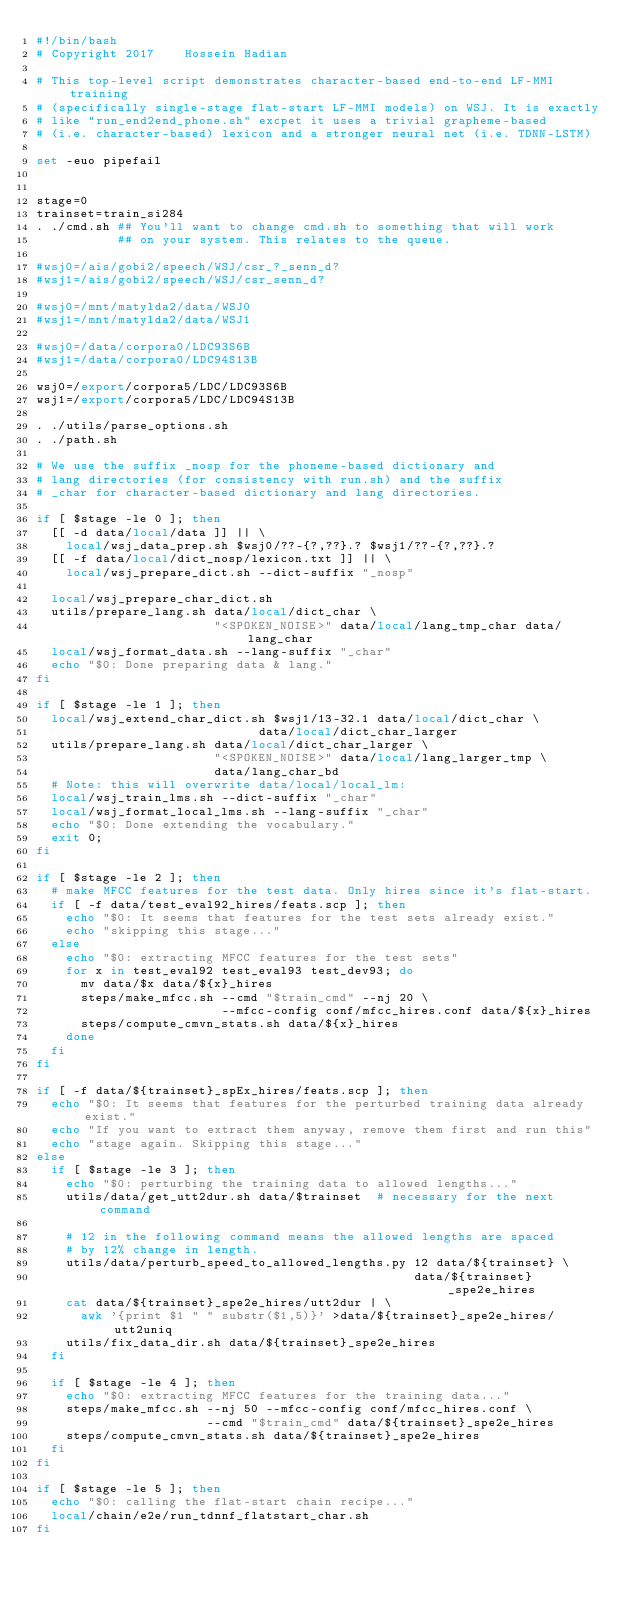<code> <loc_0><loc_0><loc_500><loc_500><_Bash_>#!/bin/bash
# Copyright 2017    Hossein Hadian

# This top-level script demonstrates character-based end-to-end LF-MMI training
# (specifically single-stage flat-start LF-MMI models) on WSJ. It is exactly
# like "run_end2end_phone.sh" excpet it uses a trivial grapheme-based
# (i.e. character-based) lexicon and a stronger neural net (i.e. TDNN-LSTM)

set -euo pipefail


stage=0
trainset=train_si284
. ./cmd.sh ## You'll want to change cmd.sh to something that will work
           ## on your system. This relates to the queue.

#wsj0=/ais/gobi2/speech/WSJ/csr_?_senn_d?
#wsj1=/ais/gobi2/speech/WSJ/csr_senn_d?

#wsj0=/mnt/matylda2/data/WSJ0
#wsj1=/mnt/matylda2/data/WSJ1

#wsj0=/data/corpora0/LDC93S6B
#wsj1=/data/corpora0/LDC94S13B

wsj0=/export/corpora5/LDC/LDC93S6B
wsj1=/export/corpora5/LDC/LDC94S13B

. ./utils/parse_options.sh
. ./path.sh

# We use the suffix _nosp for the phoneme-based dictionary and
# lang directories (for consistency with run.sh) and the suffix
# _char for character-based dictionary and lang directories.

if [ $stage -le 0 ]; then
  [[ -d data/local/data ]] || \
    local/wsj_data_prep.sh $wsj0/??-{?,??}.? $wsj1/??-{?,??}.?
  [[ -f data/local/dict_nosp/lexicon.txt ]] || \
    local/wsj_prepare_dict.sh --dict-suffix "_nosp"

  local/wsj_prepare_char_dict.sh
  utils/prepare_lang.sh data/local/dict_char \
                        "<SPOKEN_NOISE>" data/local/lang_tmp_char data/lang_char
  local/wsj_format_data.sh --lang-suffix "_char"
  echo "$0: Done preparing data & lang."
fi

if [ $stage -le 1 ]; then
  local/wsj_extend_char_dict.sh $wsj1/13-32.1 data/local/dict_char \
                              data/local/dict_char_larger
  utils/prepare_lang.sh data/local/dict_char_larger \
                        "<SPOKEN_NOISE>" data/local/lang_larger_tmp \
                        data/lang_char_bd
  # Note: this will overwrite data/local/local_lm:
  local/wsj_train_lms.sh --dict-suffix "_char"
  local/wsj_format_local_lms.sh --lang-suffix "_char"
  echo "$0: Done extending the vocabulary."
  exit 0;
fi

if [ $stage -le 2 ]; then
  # make MFCC features for the test data. Only hires since it's flat-start.
  if [ -f data/test_eval92_hires/feats.scp ]; then
    echo "$0: It seems that features for the test sets already exist."
    echo "skipping this stage..."
  else
    echo "$0: extracting MFCC features for the test sets"
    for x in test_eval92 test_eval93 test_dev93; do
      mv data/$x data/${x}_hires
      steps/make_mfcc.sh --cmd "$train_cmd" --nj 20 \
                         --mfcc-config conf/mfcc_hires.conf data/${x}_hires
      steps/compute_cmvn_stats.sh data/${x}_hires
    done
  fi
fi

if [ -f data/${trainset}_spEx_hires/feats.scp ]; then
  echo "$0: It seems that features for the perturbed training data already exist."
  echo "If you want to extract them anyway, remove them first and run this"
  echo "stage again. Skipping this stage..."
else
  if [ $stage -le 3 ]; then
    echo "$0: perturbing the training data to allowed lengths..."
    utils/data/get_utt2dur.sh data/$trainset  # necessary for the next command

    # 12 in the following command means the allowed lengths are spaced
    # by 12% change in length.
    utils/data/perturb_speed_to_allowed_lengths.py 12 data/${trainset} \
                                                   data/${trainset}_spe2e_hires
    cat data/${trainset}_spe2e_hires/utt2dur | \
      awk '{print $1 " " substr($1,5)}' >data/${trainset}_spe2e_hires/utt2uniq
    utils/fix_data_dir.sh data/${trainset}_spe2e_hires
  fi

  if [ $stage -le 4 ]; then
    echo "$0: extracting MFCC features for the training data..."
    steps/make_mfcc.sh --nj 50 --mfcc-config conf/mfcc_hires.conf \
                       --cmd "$train_cmd" data/${trainset}_spe2e_hires
    steps/compute_cmvn_stats.sh data/${trainset}_spe2e_hires
  fi
fi

if [ $stage -le 5 ]; then
  echo "$0: calling the flat-start chain recipe..."
  local/chain/e2e/run_tdnnf_flatstart_char.sh
fi
</code> 